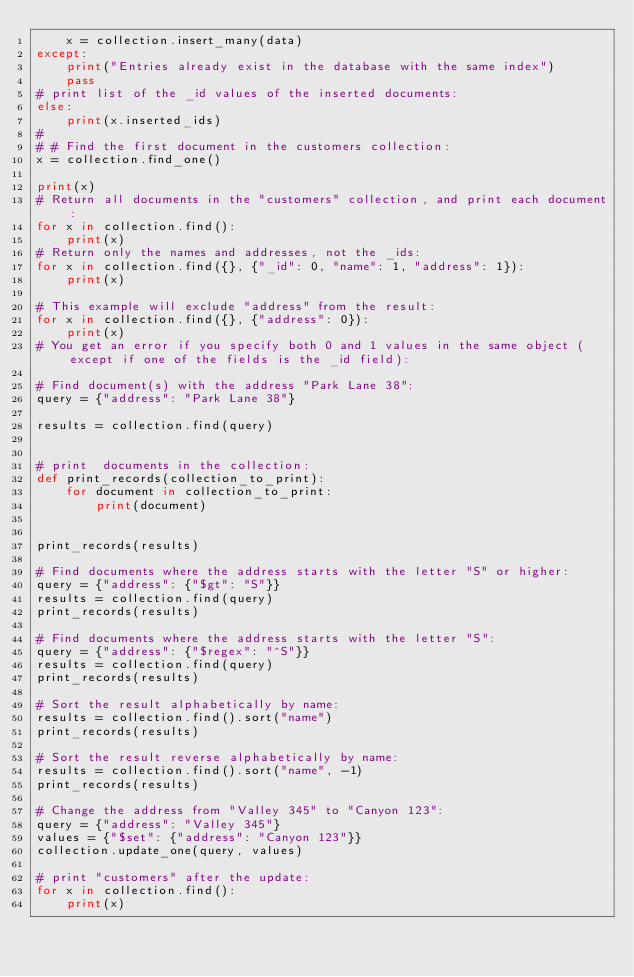Convert code to text. <code><loc_0><loc_0><loc_500><loc_500><_Python_>    x = collection.insert_many(data)
except:
    print("Entries already exist in the database with the same index")
    pass
# print list of the _id values of the inserted documents:
else:
    print(x.inserted_ids)
#
# # Find the first document in the customers collection:
x = collection.find_one()

print(x)
# Return all documents in the "customers" collection, and print each document:
for x in collection.find():
    print(x)
# Return only the names and addresses, not the _ids:
for x in collection.find({}, {"_id": 0, "name": 1, "address": 1}):
    print(x)

# This example will exclude "address" from the result:
for x in collection.find({}, {"address": 0}):
    print(x)
# You get an error if you specify both 0 and 1 values in the same object (except if one of the fields is the _id field):

# Find document(s) with the address "Park Lane 38":
query = {"address": "Park Lane 38"}

results = collection.find(query)


# print  documents in the collection:
def print_records(collection_to_print):
    for document in collection_to_print:
        print(document)


print_records(results)

# Find documents where the address starts with the letter "S" or higher:
query = {"address": {"$gt": "S"}}
results = collection.find(query)
print_records(results)

# Find documents where the address starts with the letter "S":
query = {"address": {"$regex": "^S"}}
results = collection.find(query)
print_records(results)

# Sort the result alphabetically by name:
results = collection.find().sort("name")
print_records(results)

# Sort the result reverse alphabetically by name:
results = collection.find().sort("name", -1)
print_records(results)

# Change the address from "Valley 345" to "Canyon 123":
query = {"address": "Valley 345"}
values = {"$set": {"address": "Canyon 123"}}
collection.update_one(query, values)

# print "customers" after the update:
for x in collection.find():
    print(x)
</code> 